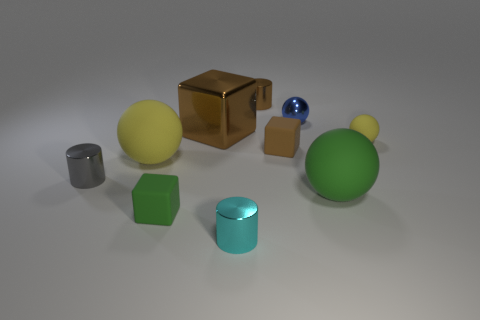Does the large sphere left of the blue object have the same color as the tiny rubber ball?
Keep it short and to the point. Yes. There is a small matte sphere; is it the same color as the rubber sphere to the left of the metal cube?
Give a very brief answer. Yes. Are there any rubber things behind the big yellow object?
Keep it short and to the point. Yes. Does the tiny cyan cylinder have the same material as the gray thing?
Offer a very short reply. Yes. What material is the gray object that is the same size as the green rubber block?
Ensure brevity in your answer.  Metal. What number of things are either large brown blocks that are to the left of the blue metallic ball or tiny gray cylinders?
Provide a short and direct response. 2. Are there the same number of small metal objects that are right of the small blue shiny object and large blue cubes?
Your answer should be compact. Yes. There is a tiny metallic cylinder that is both in front of the brown cylinder and behind the small cyan metallic thing; what color is it?
Keep it short and to the point. Gray. What number of balls are either small gray shiny things or blue things?
Offer a very short reply. 1. Is the number of metallic cylinders behind the big green thing less than the number of cylinders?
Ensure brevity in your answer.  Yes. 